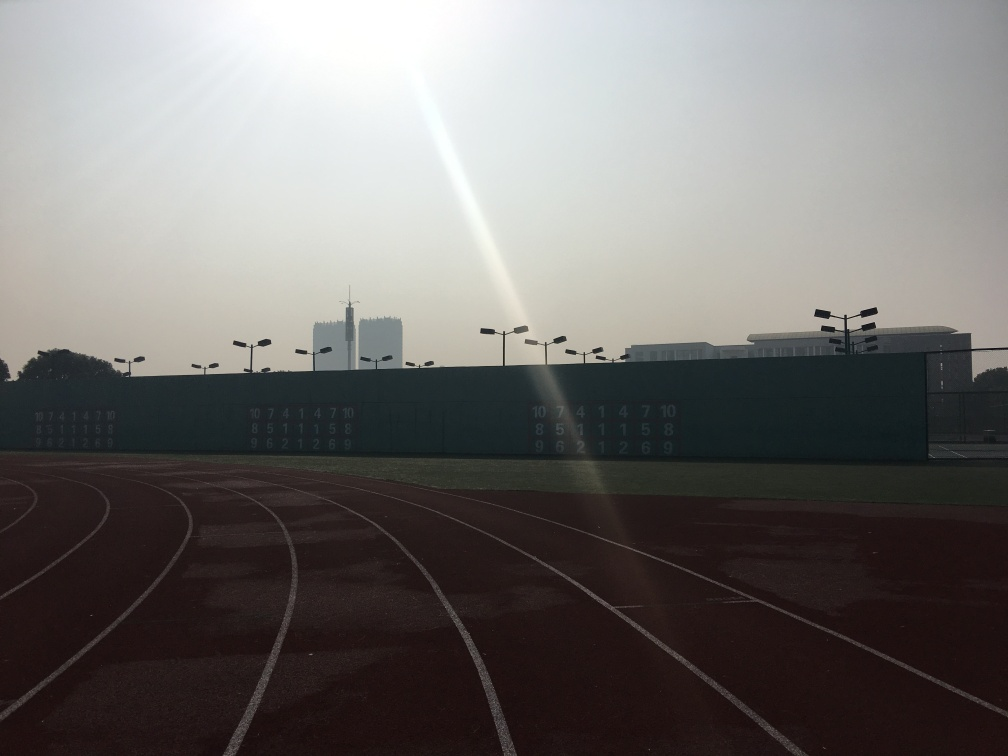Can you explain the significance of the numbers on the green wall and their arrangement? The numbers on the green wall appear to be arranged in columns, possibly indicating the lanes of the track and corresponding times or scores for track and field events. This arrangement is commonly seen at athletic fields, where such numbers are used to display results or participant numbers in a way that is easily visible to spectators and athletes. 